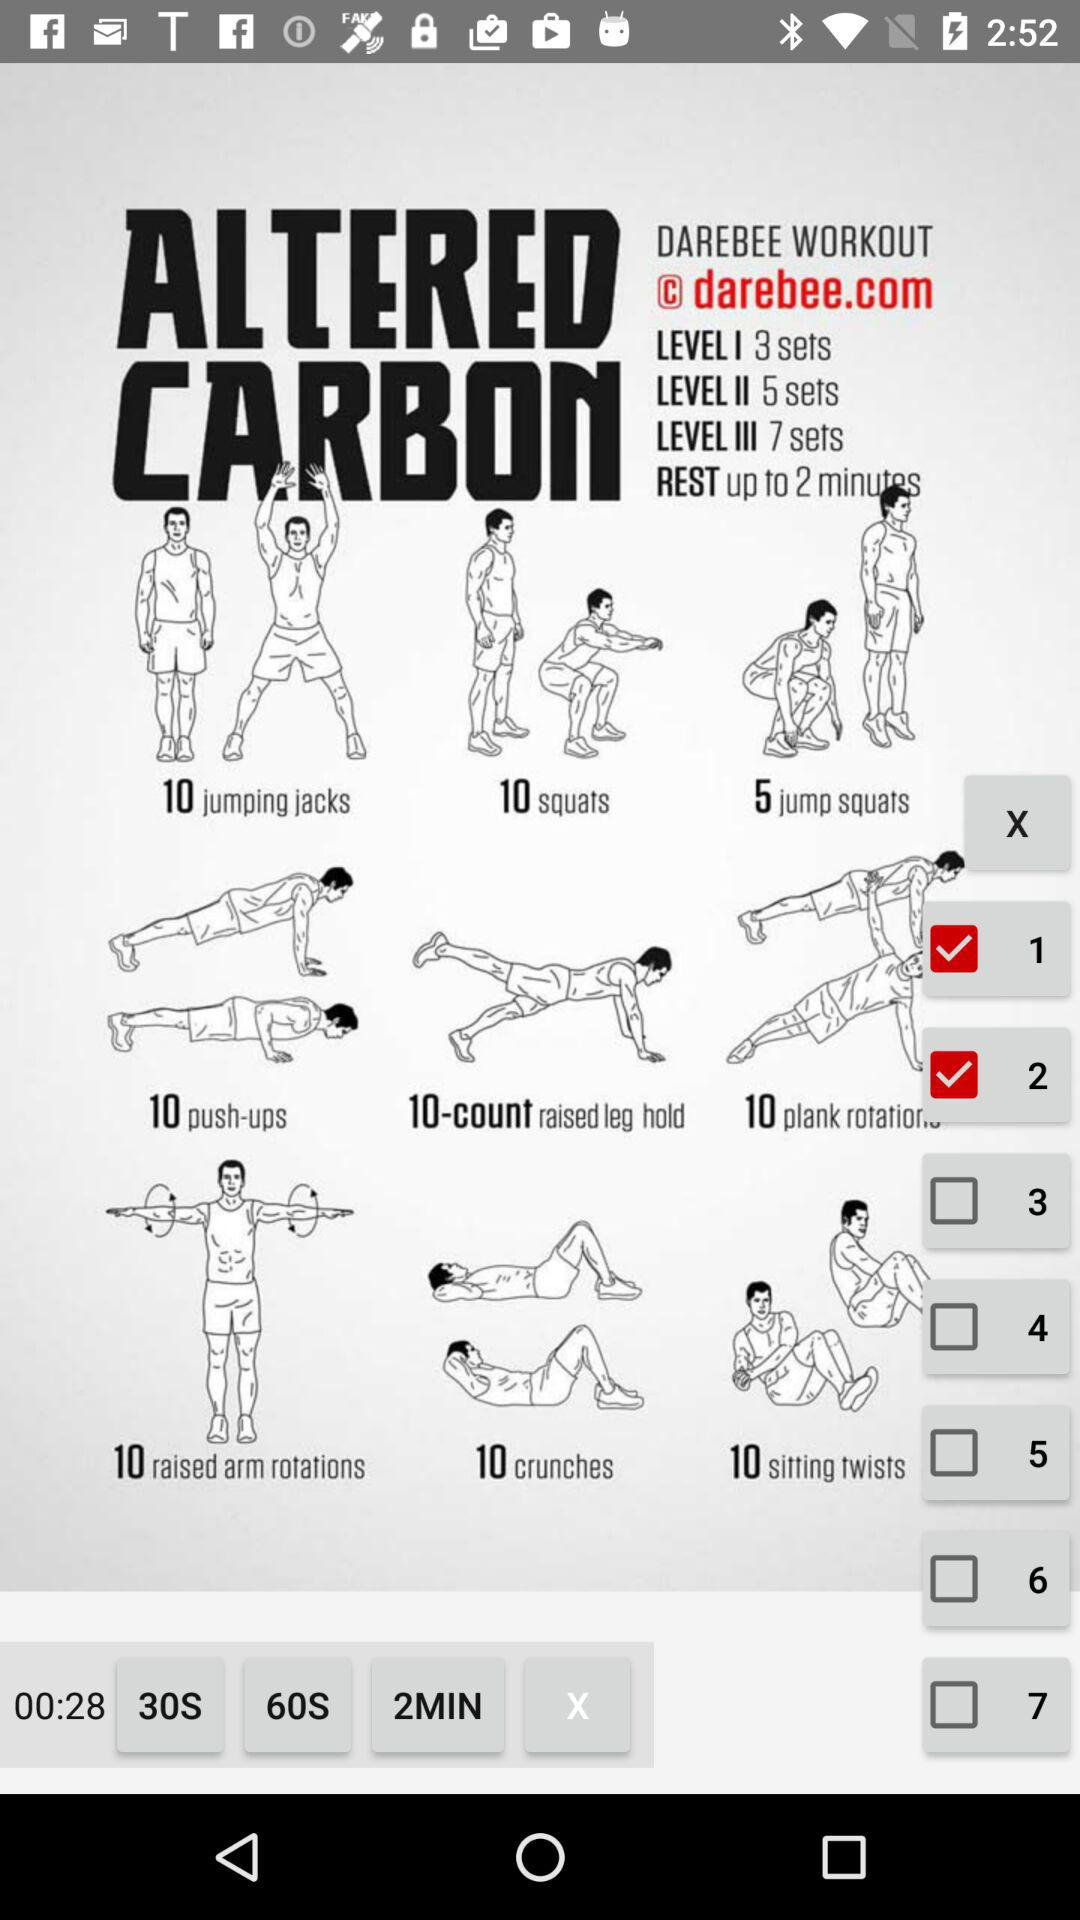How long should a workout last in minutes?
When the provided information is insufficient, respond with <no answer>. <no answer> 